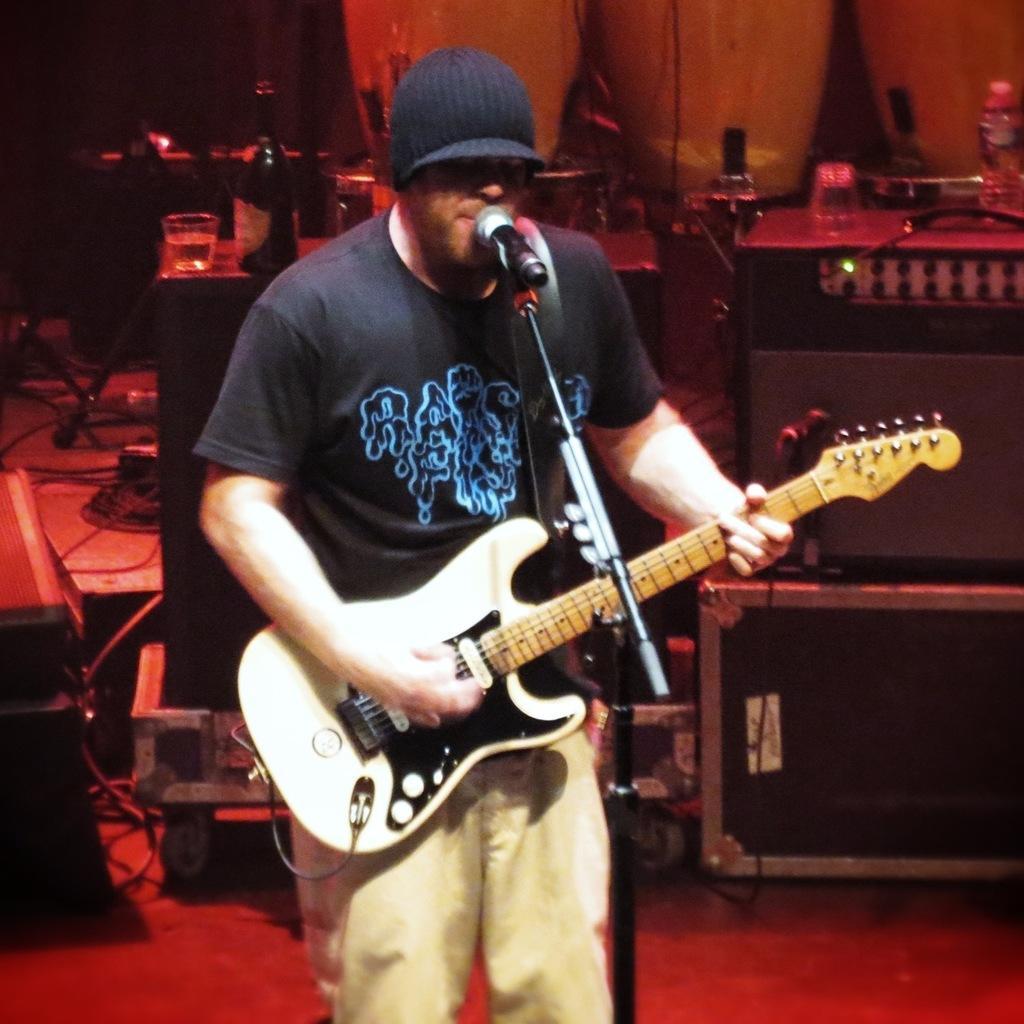Could you give a brief overview of what you see in this image? In this image I see a man who is holding the guitar and standing in front of the mic. In the background I see lot of equipment and 2 bottles over here. 